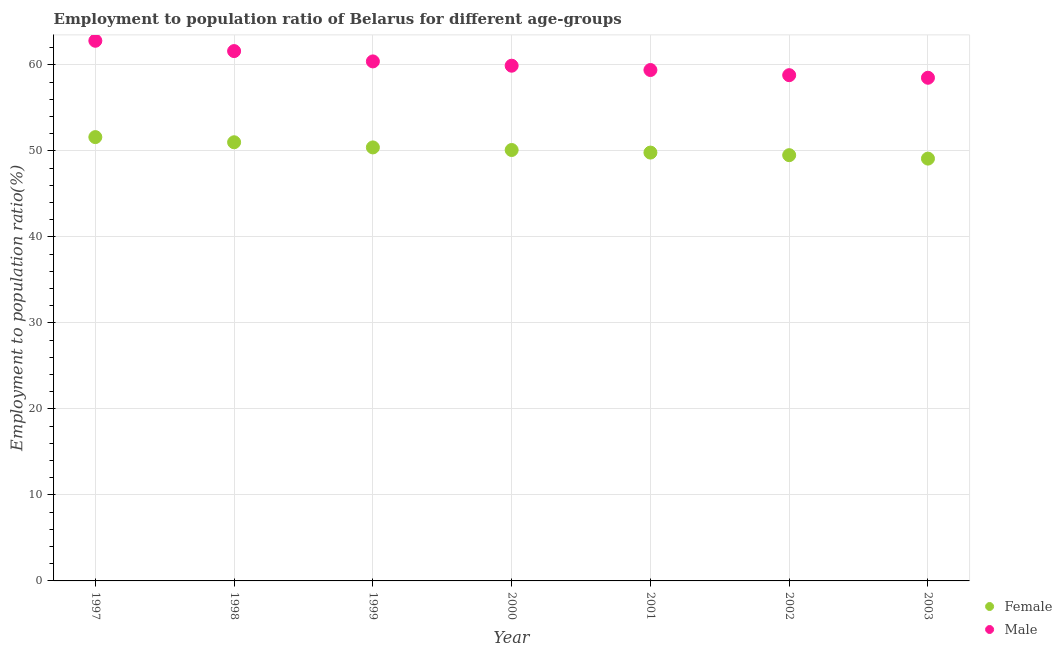How many different coloured dotlines are there?
Your answer should be very brief. 2. What is the employment to population ratio(male) in 1997?
Provide a succinct answer. 62.8. Across all years, what is the maximum employment to population ratio(male)?
Your answer should be compact. 62.8. Across all years, what is the minimum employment to population ratio(female)?
Offer a terse response. 49.1. In which year was the employment to population ratio(female) maximum?
Give a very brief answer. 1997. What is the total employment to population ratio(male) in the graph?
Give a very brief answer. 421.4. What is the difference between the employment to population ratio(male) in 1998 and that in 2002?
Ensure brevity in your answer.  2.8. What is the difference between the employment to population ratio(female) in 1997 and the employment to population ratio(male) in 2000?
Provide a succinct answer. -8.3. What is the average employment to population ratio(female) per year?
Your answer should be very brief. 50.21. In the year 2001, what is the difference between the employment to population ratio(male) and employment to population ratio(female)?
Offer a terse response. 9.6. In how many years, is the employment to population ratio(male) greater than 4 %?
Your answer should be very brief. 7. What is the ratio of the employment to population ratio(male) in 1997 to that in 2000?
Your response must be concise. 1.05. Is the employment to population ratio(female) in 2000 less than that in 2001?
Give a very brief answer. No. What is the difference between the highest and the second highest employment to population ratio(female)?
Keep it short and to the point. 0.6. What is the difference between the highest and the lowest employment to population ratio(male)?
Ensure brevity in your answer.  4.3. Is the sum of the employment to population ratio(male) in 2001 and 2002 greater than the maximum employment to population ratio(female) across all years?
Give a very brief answer. Yes. Does the employment to population ratio(female) monotonically increase over the years?
Offer a terse response. No. Is the employment to population ratio(male) strictly greater than the employment to population ratio(female) over the years?
Make the answer very short. Yes. Is the employment to population ratio(male) strictly less than the employment to population ratio(female) over the years?
Offer a terse response. No. How many dotlines are there?
Offer a terse response. 2. Does the graph contain grids?
Offer a very short reply. Yes. Where does the legend appear in the graph?
Ensure brevity in your answer.  Bottom right. What is the title of the graph?
Provide a succinct answer. Employment to population ratio of Belarus for different age-groups. Does "Study and work" appear as one of the legend labels in the graph?
Make the answer very short. No. What is the label or title of the X-axis?
Provide a succinct answer. Year. What is the Employment to population ratio(%) of Female in 1997?
Your answer should be very brief. 51.6. What is the Employment to population ratio(%) of Male in 1997?
Ensure brevity in your answer.  62.8. What is the Employment to population ratio(%) of Female in 1998?
Make the answer very short. 51. What is the Employment to population ratio(%) in Male in 1998?
Your answer should be compact. 61.6. What is the Employment to population ratio(%) in Female in 1999?
Offer a very short reply. 50.4. What is the Employment to population ratio(%) of Male in 1999?
Ensure brevity in your answer.  60.4. What is the Employment to population ratio(%) of Female in 2000?
Ensure brevity in your answer.  50.1. What is the Employment to population ratio(%) of Male in 2000?
Provide a succinct answer. 59.9. What is the Employment to population ratio(%) of Female in 2001?
Offer a terse response. 49.8. What is the Employment to population ratio(%) in Male in 2001?
Make the answer very short. 59.4. What is the Employment to population ratio(%) in Female in 2002?
Your answer should be compact. 49.5. What is the Employment to population ratio(%) in Male in 2002?
Your response must be concise. 58.8. What is the Employment to population ratio(%) in Female in 2003?
Your answer should be compact. 49.1. What is the Employment to population ratio(%) of Male in 2003?
Provide a succinct answer. 58.5. Across all years, what is the maximum Employment to population ratio(%) of Female?
Offer a terse response. 51.6. Across all years, what is the maximum Employment to population ratio(%) in Male?
Give a very brief answer. 62.8. Across all years, what is the minimum Employment to population ratio(%) in Female?
Your response must be concise. 49.1. Across all years, what is the minimum Employment to population ratio(%) of Male?
Give a very brief answer. 58.5. What is the total Employment to population ratio(%) in Female in the graph?
Make the answer very short. 351.5. What is the total Employment to population ratio(%) in Male in the graph?
Make the answer very short. 421.4. What is the difference between the Employment to population ratio(%) in Male in 1997 and that in 1998?
Provide a succinct answer. 1.2. What is the difference between the Employment to population ratio(%) in Female in 1997 and that in 2000?
Offer a terse response. 1.5. What is the difference between the Employment to population ratio(%) of Male in 1997 and that in 2000?
Make the answer very short. 2.9. What is the difference between the Employment to population ratio(%) in Female in 1997 and that in 2001?
Provide a short and direct response. 1.8. What is the difference between the Employment to population ratio(%) of Male in 1997 and that in 2001?
Keep it short and to the point. 3.4. What is the difference between the Employment to population ratio(%) in Female in 1998 and that in 1999?
Your answer should be compact. 0.6. What is the difference between the Employment to population ratio(%) of Female in 1998 and that in 2001?
Offer a very short reply. 1.2. What is the difference between the Employment to population ratio(%) in Female in 1998 and that in 2002?
Your response must be concise. 1.5. What is the difference between the Employment to population ratio(%) of Male in 1998 and that in 2002?
Make the answer very short. 2.8. What is the difference between the Employment to population ratio(%) in Male in 1998 and that in 2003?
Keep it short and to the point. 3.1. What is the difference between the Employment to population ratio(%) in Male in 1999 and that in 2000?
Offer a very short reply. 0.5. What is the difference between the Employment to population ratio(%) of Male in 1999 and that in 2002?
Ensure brevity in your answer.  1.6. What is the difference between the Employment to population ratio(%) in Male in 1999 and that in 2003?
Keep it short and to the point. 1.9. What is the difference between the Employment to population ratio(%) of Female in 2000 and that in 2001?
Offer a very short reply. 0.3. What is the difference between the Employment to population ratio(%) in Male in 2000 and that in 2001?
Provide a succinct answer. 0.5. What is the difference between the Employment to population ratio(%) in Female in 2000 and that in 2002?
Make the answer very short. 0.6. What is the difference between the Employment to population ratio(%) of Male in 2000 and that in 2002?
Provide a short and direct response. 1.1. What is the difference between the Employment to population ratio(%) of Female in 2001 and that in 2002?
Your response must be concise. 0.3. What is the difference between the Employment to population ratio(%) in Male in 2001 and that in 2002?
Offer a terse response. 0.6. What is the difference between the Employment to population ratio(%) in Female in 2001 and that in 2003?
Keep it short and to the point. 0.7. What is the difference between the Employment to population ratio(%) in Male in 2001 and that in 2003?
Make the answer very short. 0.9. What is the difference between the Employment to population ratio(%) in Male in 2002 and that in 2003?
Your answer should be compact. 0.3. What is the difference between the Employment to population ratio(%) in Female in 1997 and the Employment to population ratio(%) in Male in 2002?
Offer a terse response. -7.2. What is the difference between the Employment to population ratio(%) of Female in 1997 and the Employment to population ratio(%) of Male in 2003?
Provide a short and direct response. -6.9. What is the difference between the Employment to population ratio(%) in Female in 1998 and the Employment to population ratio(%) in Male in 2000?
Your answer should be compact. -8.9. What is the difference between the Employment to population ratio(%) of Female in 1998 and the Employment to population ratio(%) of Male in 2002?
Your response must be concise. -7.8. What is the difference between the Employment to population ratio(%) in Female in 1999 and the Employment to population ratio(%) in Male in 2001?
Give a very brief answer. -9. What is the difference between the Employment to population ratio(%) of Female in 2000 and the Employment to population ratio(%) of Male in 2001?
Keep it short and to the point. -9.3. What is the difference between the Employment to population ratio(%) of Female in 2000 and the Employment to population ratio(%) of Male in 2002?
Provide a succinct answer. -8.7. What is the difference between the Employment to population ratio(%) of Female in 2002 and the Employment to population ratio(%) of Male in 2003?
Offer a very short reply. -9. What is the average Employment to population ratio(%) in Female per year?
Ensure brevity in your answer.  50.21. What is the average Employment to population ratio(%) in Male per year?
Offer a terse response. 60.2. In the year 2002, what is the difference between the Employment to population ratio(%) of Female and Employment to population ratio(%) of Male?
Offer a terse response. -9.3. What is the ratio of the Employment to population ratio(%) in Female in 1997 to that in 1998?
Your response must be concise. 1.01. What is the ratio of the Employment to population ratio(%) of Male in 1997 to that in 1998?
Make the answer very short. 1.02. What is the ratio of the Employment to population ratio(%) in Female in 1997 to that in 1999?
Provide a short and direct response. 1.02. What is the ratio of the Employment to population ratio(%) of Male in 1997 to that in 1999?
Give a very brief answer. 1.04. What is the ratio of the Employment to population ratio(%) of Female in 1997 to that in 2000?
Your response must be concise. 1.03. What is the ratio of the Employment to population ratio(%) of Male in 1997 to that in 2000?
Offer a terse response. 1.05. What is the ratio of the Employment to population ratio(%) of Female in 1997 to that in 2001?
Keep it short and to the point. 1.04. What is the ratio of the Employment to population ratio(%) in Male in 1997 to that in 2001?
Give a very brief answer. 1.06. What is the ratio of the Employment to population ratio(%) in Female in 1997 to that in 2002?
Offer a very short reply. 1.04. What is the ratio of the Employment to population ratio(%) of Male in 1997 to that in 2002?
Ensure brevity in your answer.  1.07. What is the ratio of the Employment to population ratio(%) of Female in 1997 to that in 2003?
Offer a terse response. 1.05. What is the ratio of the Employment to population ratio(%) in Male in 1997 to that in 2003?
Provide a short and direct response. 1.07. What is the ratio of the Employment to population ratio(%) of Female in 1998 to that in 1999?
Your response must be concise. 1.01. What is the ratio of the Employment to population ratio(%) in Male in 1998 to that in 1999?
Make the answer very short. 1.02. What is the ratio of the Employment to population ratio(%) in Female in 1998 to that in 2000?
Offer a terse response. 1.02. What is the ratio of the Employment to population ratio(%) of Male in 1998 to that in 2000?
Offer a terse response. 1.03. What is the ratio of the Employment to population ratio(%) of Female in 1998 to that in 2001?
Make the answer very short. 1.02. What is the ratio of the Employment to population ratio(%) of Male in 1998 to that in 2001?
Offer a terse response. 1.04. What is the ratio of the Employment to population ratio(%) of Female in 1998 to that in 2002?
Offer a terse response. 1.03. What is the ratio of the Employment to population ratio(%) of Male in 1998 to that in 2002?
Provide a succinct answer. 1.05. What is the ratio of the Employment to population ratio(%) in Female in 1998 to that in 2003?
Ensure brevity in your answer.  1.04. What is the ratio of the Employment to population ratio(%) of Male in 1998 to that in 2003?
Offer a terse response. 1.05. What is the ratio of the Employment to population ratio(%) in Female in 1999 to that in 2000?
Offer a very short reply. 1.01. What is the ratio of the Employment to population ratio(%) of Male in 1999 to that in 2000?
Your answer should be very brief. 1.01. What is the ratio of the Employment to population ratio(%) in Female in 1999 to that in 2001?
Provide a short and direct response. 1.01. What is the ratio of the Employment to population ratio(%) of Male in 1999 to that in 2001?
Your answer should be very brief. 1.02. What is the ratio of the Employment to population ratio(%) of Female in 1999 to that in 2002?
Offer a very short reply. 1.02. What is the ratio of the Employment to population ratio(%) in Male in 1999 to that in 2002?
Offer a terse response. 1.03. What is the ratio of the Employment to population ratio(%) in Female in 1999 to that in 2003?
Make the answer very short. 1.03. What is the ratio of the Employment to population ratio(%) in Male in 1999 to that in 2003?
Make the answer very short. 1.03. What is the ratio of the Employment to population ratio(%) in Male in 2000 to that in 2001?
Your answer should be compact. 1.01. What is the ratio of the Employment to population ratio(%) of Female in 2000 to that in 2002?
Offer a very short reply. 1.01. What is the ratio of the Employment to population ratio(%) in Male in 2000 to that in 2002?
Keep it short and to the point. 1.02. What is the ratio of the Employment to population ratio(%) of Female in 2000 to that in 2003?
Your answer should be compact. 1.02. What is the ratio of the Employment to population ratio(%) of Male in 2000 to that in 2003?
Offer a terse response. 1.02. What is the ratio of the Employment to population ratio(%) in Female in 2001 to that in 2002?
Provide a succinct answer. 1.01. What is the ratio of the Employment to population ratio(%) in Male in 2001 to that in 2002?
Provide a short and direct response. 1.01. What is the ratio of the Employment to population ratio(%) of Female in 2001 to that in 2003?
Keep it short and to the point. 1.01. What is the ratio of the Employment to population ratio(%) in Male in 2001 to that in 2003?
Offer a terse response. 1.02. What is the ratio of the Employment to population ratio(%) of Female in 2002 to that in 2003?
Keep it short and to the point. 1.01. What is the ratio of the Employment to population ratio(%) in Male in 2002 to that in 2003?
Provide a short and direct response. 1.01. What is the difference between the highest and the lowest Employment to population ratio(%) in Male?
Your response must be concise. 4.3. 